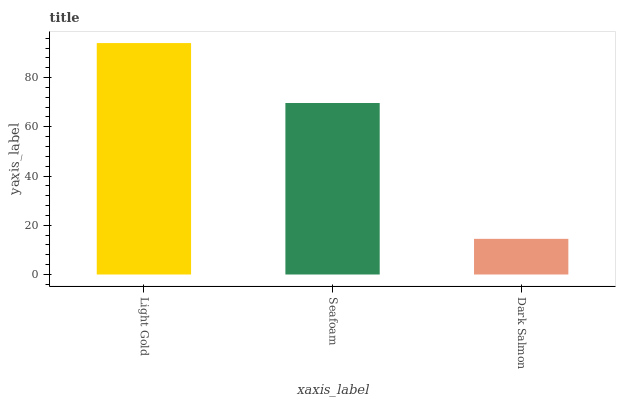Is Dark Salmon the minimum?
Answer yes or no. Yes. Is Light Gold the maximum?
Answer yes or no. Yes. Is Seafoam the minimum?
Answer yes or no. No. Is Seafoam the maximum?
Answer yes or no. No. Is Light Gold greater than Seafoam?
Answer yes or no. Yes. Is Seafoam less than Light Gold?
Answer yes or no. Yes. Is Seafoam greater than Light Gold?
Answer yes or no. No. Is Light Gold less than Seafoam?
Answer yes or no. No. Is Seafoam the high median?
Answer yes or no. Yes. Is Seafoam the low median?
Answer yes or no. Yes. Is Light Gold the high median?
Answer yes or no. No. Is Dark Salmon the low median?
Answer yes or no. No. 